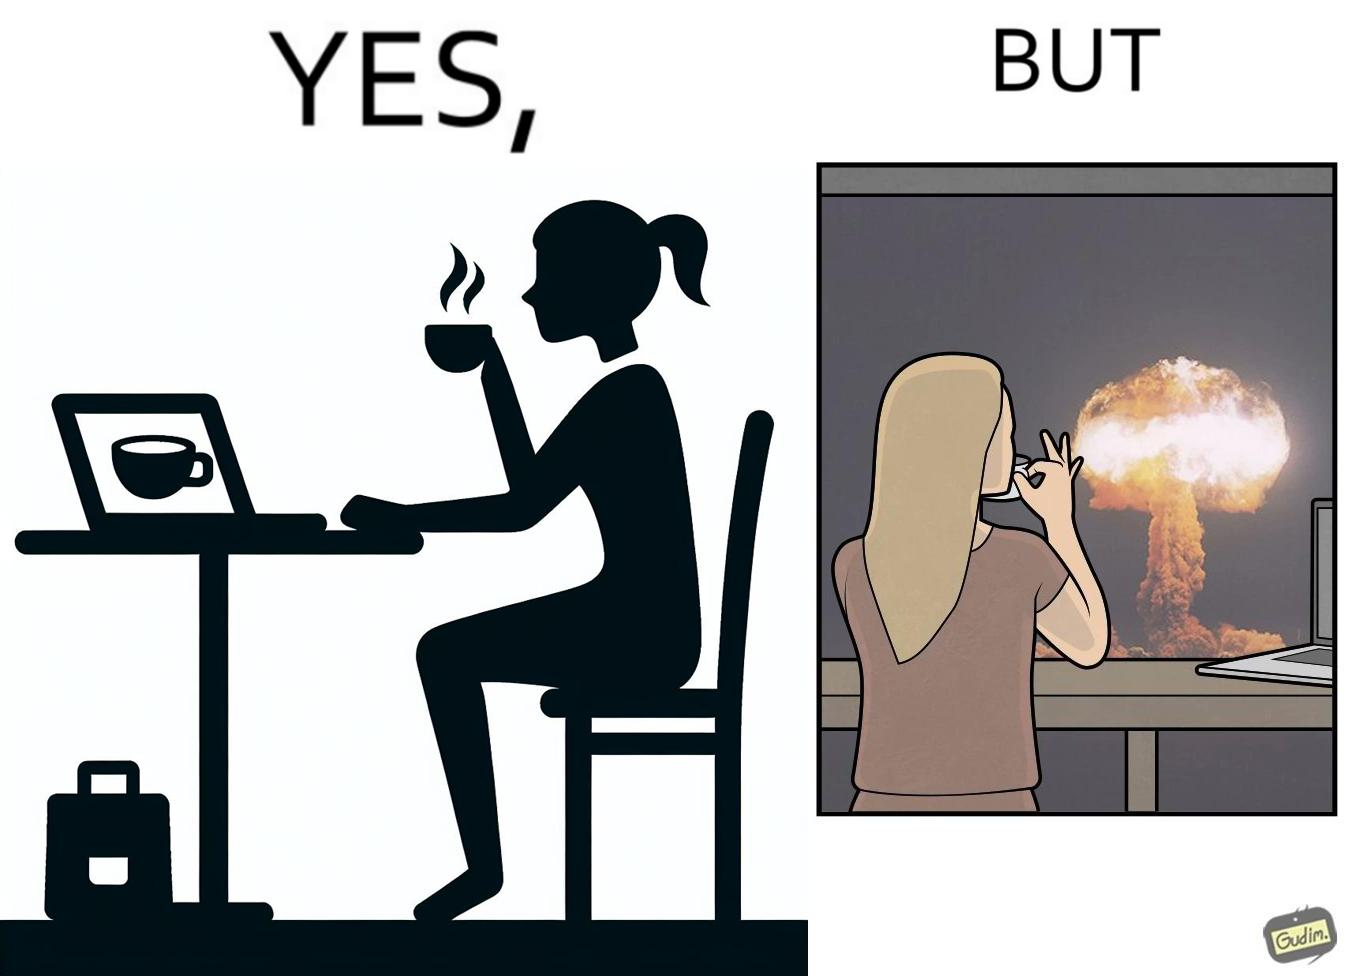What is the satirical meaning behind this image? The images are funny since it shows a woman simply sipping from a cup at ease in a cafe with her laptop not caring about anything going on outside the cafe even though the situation is very grave,that is, a nuclear blast 